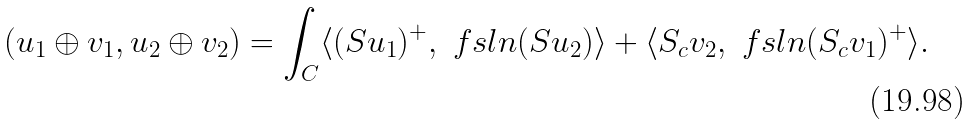<formula> <loc_0><loc_0><loc_500><loc_500>( u _ { 1 } \oplus v _ { 1 } , u _ { 2 } \oplus v _ { 2 } ) = \int _ { C } \langle ( S u _ { 1 } ) ^ { + } , \ f s l { n } ( S u _ { 2 } ) \rangle + \langle S _ { c } v _ { 2 } , \ f s l { n } ( S _ { c } v _ { 1 } ) ^ { + } \rangle .</formula> 